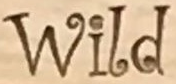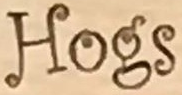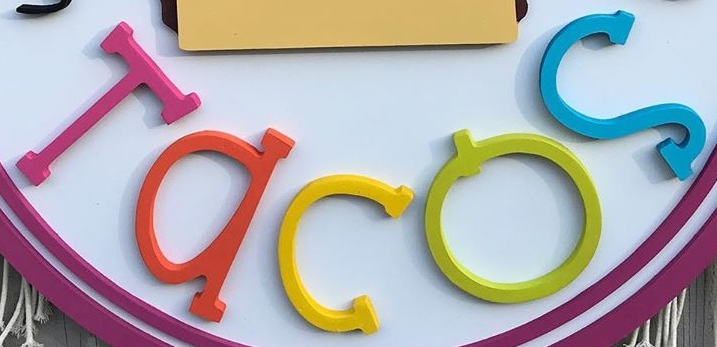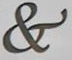What words can you see in these images in sequence, separated by a semicolon? Wild; Hogs; Tacos; & 